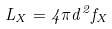Convert formula to latex. <formula><loc_0><loc_0><loc_500><loc_500>L _ { X } = 4 \pi d ^ { 2 } f _ { X }</formula> 